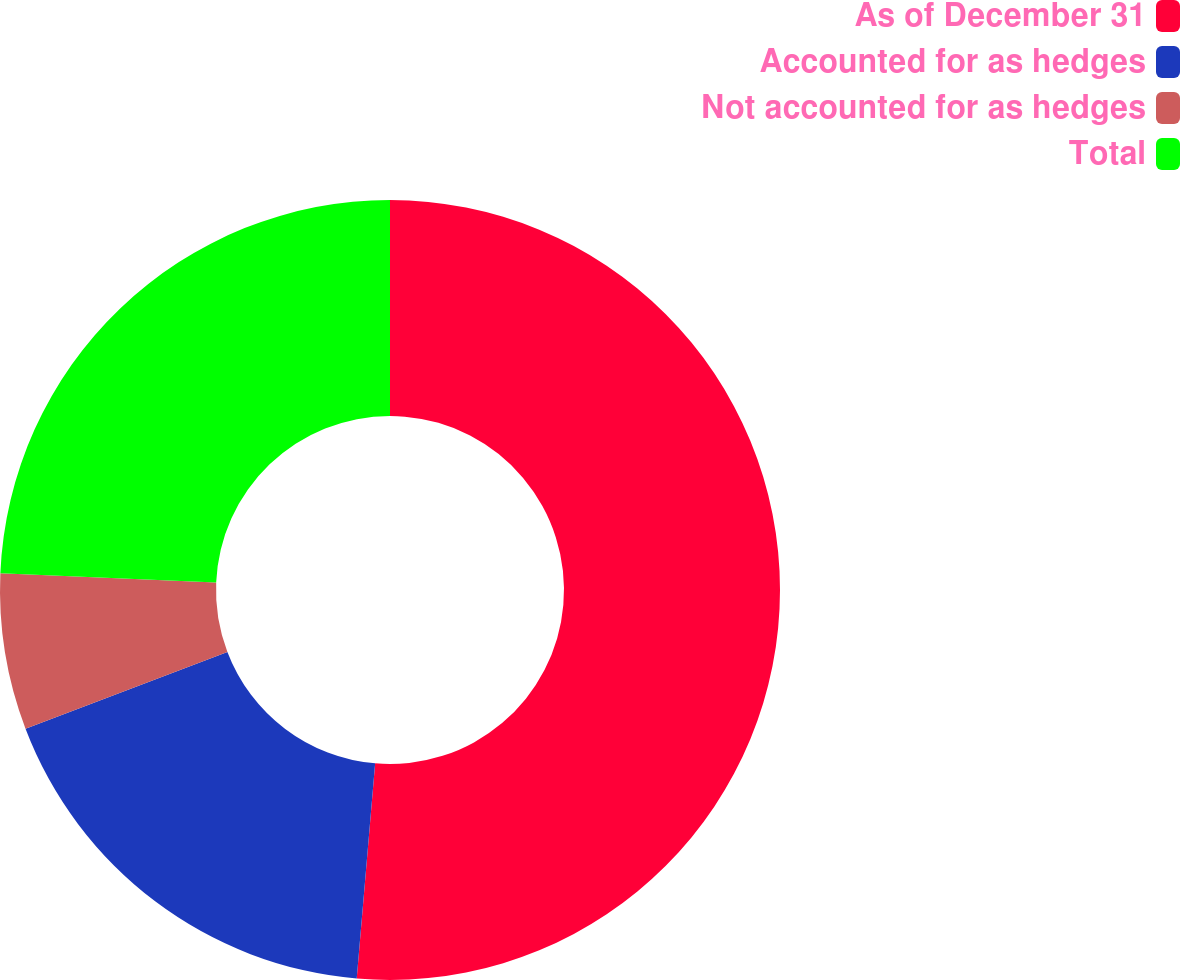Convert chart. <chart><loc_0><loc_0><loc_500><loc_500><pie_chart><fcel>As of December 31<fcel>Accounted for as hedges<fcel>Not accounted for as hedges<fcel>Total<nl><fcel>51.36%<fcel>17.85%<fcel>6.47%<fcel>24.32%<nl></chart> 